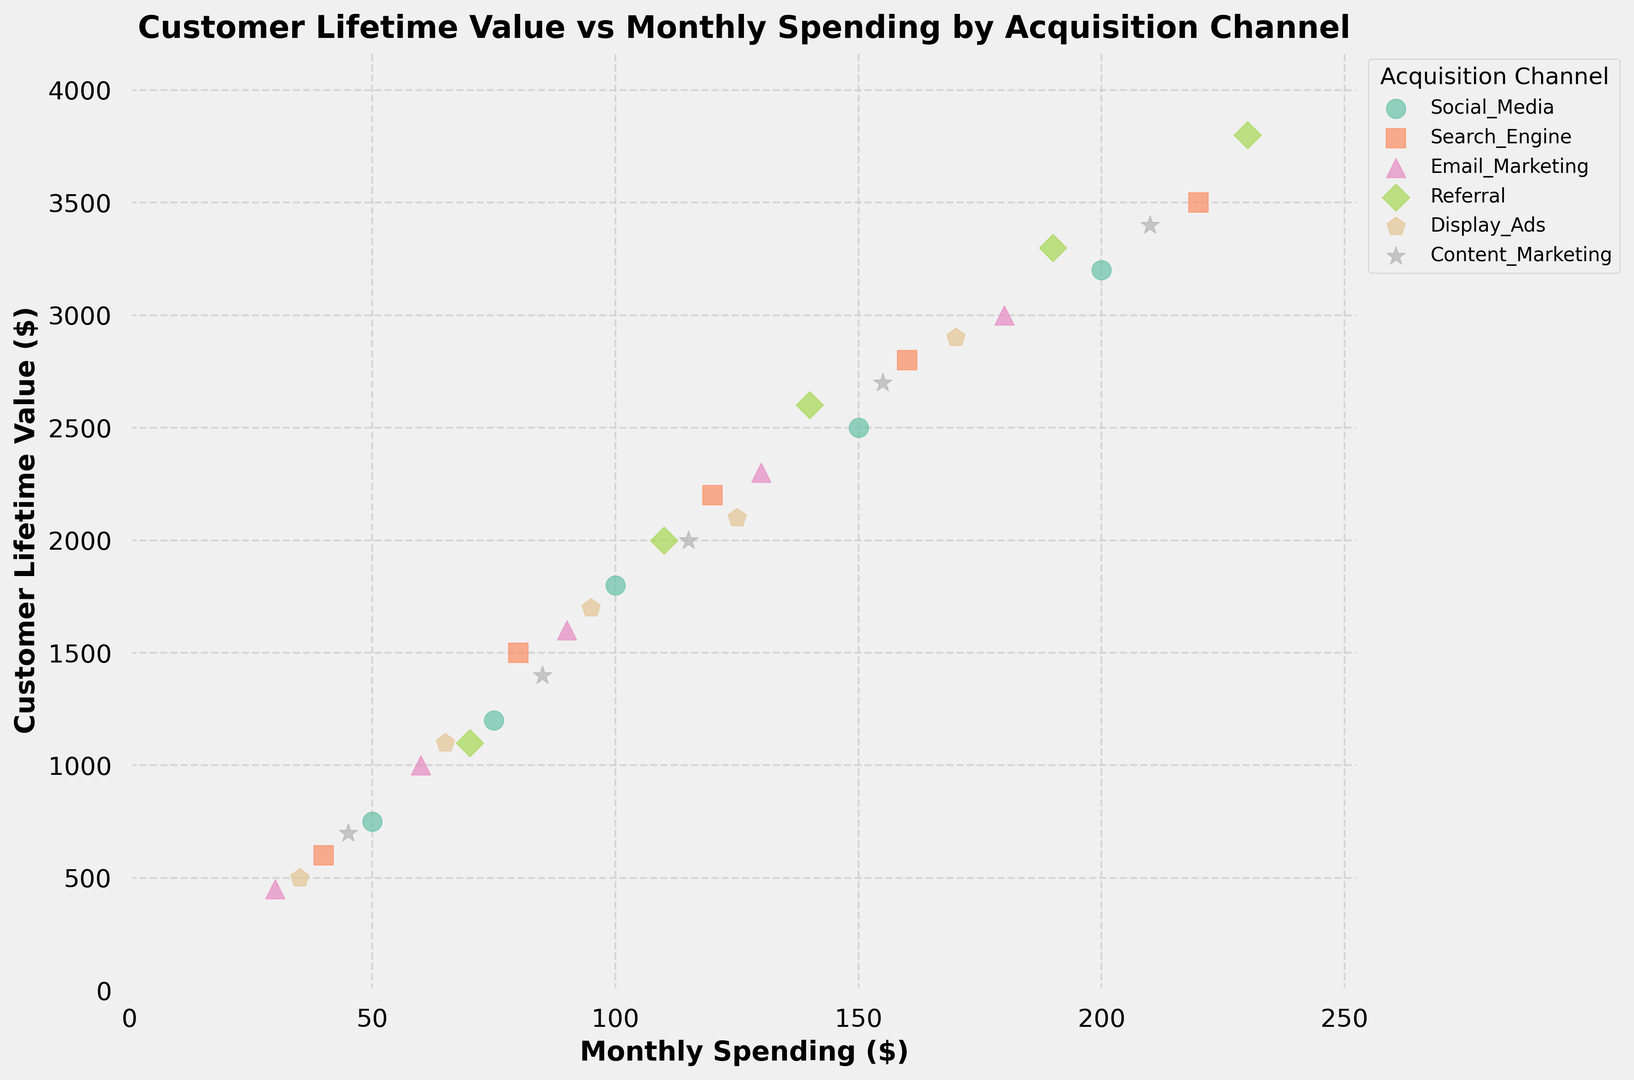What acquisition channel shows the highest Customer Lifetime Value (CLV) at the highest Monthly Spending level? First, identify the plot data point with the highest Monthly Spending value. Then, observe the corresponding acquisition channel for the highest CLV among these values.
Answer: Referral Which acquisition channel has the lowest overall Customer Lifetime Value for Monthly Spending around $50? Locate the data points with Monthly Spending around $50. Identify the one with the lowest CLV and note its acquisition channel.
Answer: Email Marketing What is the range of Customer Lifetime Values for Social Media channels when Monthly Spending is less than $100? Extract the data points related to Social Media from the plot where Monthly Spending is less than $100. Calculate the range of these values by subtracting the minimum CLV from the maximum CLV.
Answer: 1050 Compare the Customer Lifetime Values between Search Engine and Display Ads for Monthly Spending of $120. Which is higher and by how much? Find the CLV for both Search Engine and Display Ads data points at Monthly Spending of $120. Subtract the CLV of Display Ads from Search Engine. Evaluate which is higher and state the difference.
Answer: Search Engine, by $500 Which acquisition channel shows more variability in Customer Lifetime Value as Monthly Spending increases? Examine the spread and distribution of the data points vertically across different Monthly Spending levels for each acquisition channel. Identify which channel shows a wider spread in CLV values with increasing Monthly Spending.
Answer: Referral What is the average Customer Lifetime Value for the Email Marketing channel? Sum the CLV values for all data points in the Email Marketing channel and divide by the number of data points in this channel.
Answer: $1670 When Monthly Spending is $200, which acquisition channel yields the lowest Customer Lifetime Value? Identify the data points with a Monthly Spending of $200 and compare their CLVs. Note down the acquisition channel associated with the lowest CLV.
Answer: Social Media How do the trends of Customer Lifetime Value versus Monthly Spending differ between Social Media and Content Marketing? Look for the pattern and slope of data points related to Social Media and Content Marketing across varying Monthly Spending levels. Compare their increase or decrease trends in CLV as Monthly Spending increases.
Answer: Social Media trends upward less steeply compared to Content Marketing Is there any acquisition channel where an increase in Monthly Spending does not lead to a significant increase in Customer Lifetime Value? Evaluate the graph trajectory for each acquisition channel. Identify any channel where the data points do not show a marked increase in CLV with higher Monthly Spending.
Answer: Display Ads 